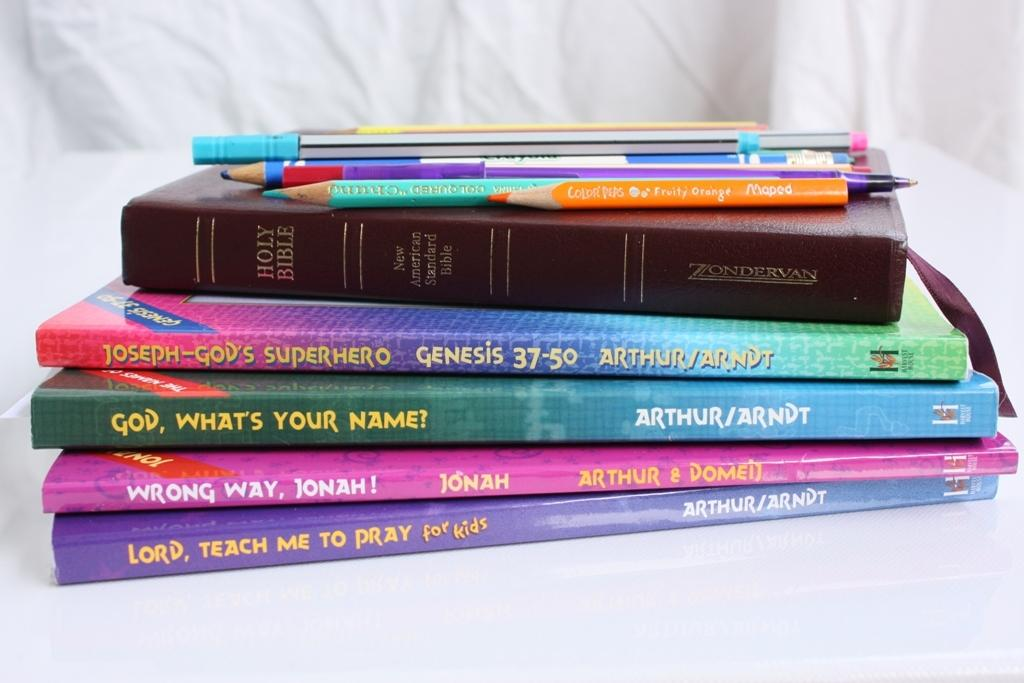<image>
Share a concise interpretation of the image provided. Four books with titles about God,and the Holy Bible, are all stacked together with pencils and pens atop the pile. 